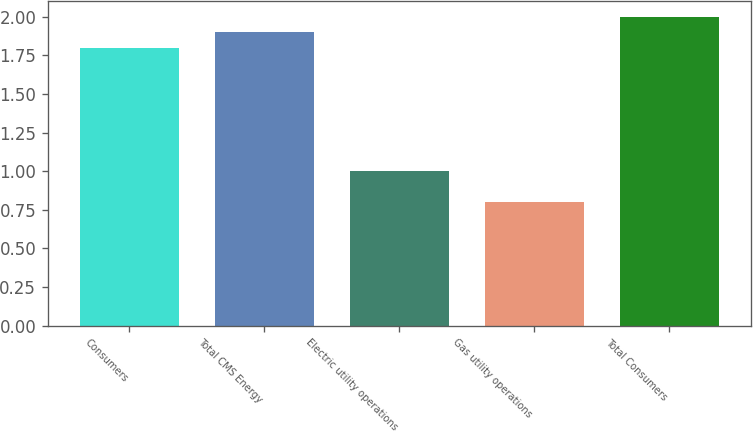Convert chart. <chart><loc_0><loc_0><loc_500><loc_500><bar_chart><fcel>Consumers<fcel>Total CMS Energy<fcel>Electric utility operations<fcel>Gas utility operations<fcel>Total Consumers<nl><fcel>1.8<fcel>1.9<fcel>1<fcel>0.8<fcel>2<nl></chart> 